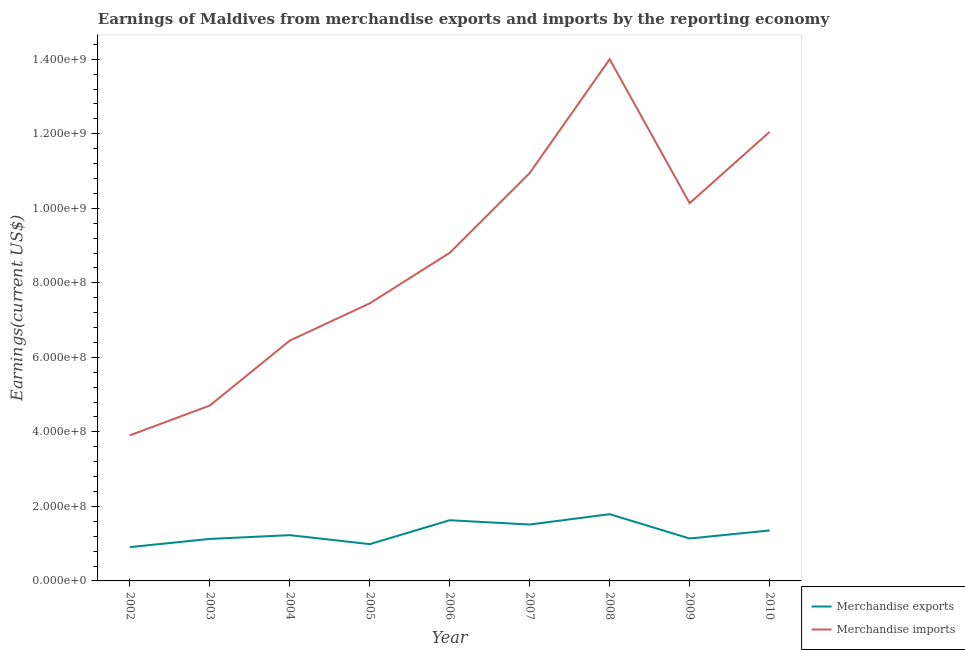How many different coloured lines are there?
Offer a very short reply. 2. Is the number of lines equal to the number of legend labels?
Make the answer very short. Yes. What is the earnings from merchandise exports in 2010?
Your response must be concise. 1.35e+08. Across all years, what is the maximum earnings from merchandise exports?
Make the answer very short. 1.79e+08. Across all years, what is the minimum earnings from merchandise exports?
Your response must be concise. 9.07e+07. In which year was the earnings from merchandise imports maximum?
Offer a very short reply. 2008. In which year was the earnings from merchandise imports minimum?
Give a very brief answer. 2002. What is the total earnings from merchandise imports in the graph?
Offer a terse response. 7.85e+09. What is the difference between the earnings from merchandise imports in 2002 and that in 2003?
Keep it short and to the point. -7.99e+07. What is the difference between the earnings from merchandise imports in 2002 and the earnings from merchandise exports in 2008?
Make the answer very short. 2.12e+08. What is the average earnings from merchandise exports per year?
Provide a succinct answer. 1.30e+08. In the year 2010, what is the difference between the earnings from merchandise imports and earnings from merchandise exports?
Offer a very short reply. 1.07e+09. What is the ratio of the earnings from merchandise imports in 2007 to that in 2010?
Offer a terse response. 0.91. Is the difference between the earnings from merchandise exports in 2008 and 2009 greater than the difference between the earnings from merchandise imports in 2008 and 2009?
Offer a very short reply. No. What is the difference between the highest and the second highest earnings from merchandise imports?
Make the answer very short. 1.95e+08. What is the difference between the highest and the lowest earnings from merchandise exports?
Offer a terse response. 8.84e+07. Is the sum of the earnings from merchandise exports in 2002 and 2007 greater than the maximum earnings from merchandise imports across all years?
Make the answer very short. No. Does the earnings from merchandise exports monotonically increase over the years?
Your answer should be compact. No. Is the earnings from merchandise imports strictly greater than the earnings from merchandise exports over the years?
Provide a short and direct response. Yes. How many lines are there?
Ensure brevity in your answer.  2. How many years are there in the graph?
Make the answer very short. 9. What is the difference between two consecutive major ticks on the Y-axis?
Give a very brief answer. 2.00e+08. How many legend labels are there?
Provide a succinct answer. 2. How are the legend labels stacked?
Give a very brief answer. Vertical. What is the title of the graph?
Make the answer very short. Earnings of Maldives from merchandise exports and imports by the reporting economy. What is the label or title of the Y-axis?
Provide a succinct answer. Earnings(current US$). What is the Earnings(current US$) in Merchandise exports in 2002?
Make the answer very short. 9.07e+07. What is the Earnings(current US$) in Merchandise imports in 2002?
Provide a short and direct response. 3.91e+08. What is the Earnings(current US$) in Merchandise exports in 2003?
Make the answer very short. 1.13e+08. What is the Earnings(current US$) in Merchandise imports in 2003?
Your response must be concise. 4.71e+08. What is the Earnings(current US$) of Merchandise exports in 2004?
Offer a terse response. 1.23e+08. What is the Earnings(current US$) in Merchandise imports in 2004?
Provide a succinct answer. 6.45e+08. What is the Earnings(current US$) in Merchandise exports in 2005?
Make the answer very short. 9.87e+07. What is the Earnings(current US$) in Merchandise imports in 2005?
Offer a very short reply. 7.45e+08. What is the Earnings(current US$) of Merchandise exports in 2006?
Your answer should be very brief. 1.63e+08. What is the Earnings(current US$) of Merchandise imports in 2006?
Give a very brief answer. 8.81e+08. What is the Earnings(current US$) in Merchandise exports in 2007?
Provide a succinct answer. 1.51e+08. What is the Earnings(current US$) in Merchandise imports in 2007?
Offer a terse response. 1.09e+09. What is the Earnings(current US$) of Merchandise exports in 2008?
Provide a succinct answer. 1.79e+08. What is the Earnings(current US$) in Merchandise imports in 2008?
Make the answer very short. 1.40e+09. What is the Earnings(current US$) in Merchandise exports in 2009?
Keep it short and to the point. 1.14e+08. What is the Earnings(current US$) of Merchandise imports in 2009?
Offer a terse response. 1.01e+09. What is the Earnings(current US$) in Merchandise exports in 2010?
Your answer should be very brief. 1.35e+08. What is the Earnings(current US$) in Merchandise imports in 2010?
Provide a short and direct response. 1.20e+09. Across all years, what is the maximum Earnings(current US$) of Merchandise exports?
Keep it short and to the point. 1.79e+08. Across all years, what is the maximum Earnings(current US$) of Merchandise imports?
Give a very brief answer. 1.40e+09. Across all years, what is the minimum Earnings(current US$) of Merchandise exports?
Your answer should be very brief. 9.07e+07. Across all years, what is the minimum Earnings(current US$) in Merchandise imports?
Ensure brevity in your answer.  3.91e+08. What is the total Earnings(current US$) in Merchandise exports in the graph?
Provide a succinct answer. 1.17e+09. What is the total Earnings(current US$) in Merchandise imports in the graph?
Make the answer very short. 7.85e+09. What is the difference between the Earnings(current US$) of Merchandise exports in 2002 and that in 2003?
Give a very brief answer. -2.20e+07. What is the difference between the Earnings(current US$) of Merchandise imports in 2002 and that in 2003?
Offer a terse response. -7.99e+07. What is the difference between the Earnings(current US$) of Merchandise exports in 2002 and that in 2004?
Make the answer very short. -3.21e+07. What is the difference between the Earnings(current US$) in Merchandise imports in 2002 and that in 2004?
Give a very brief answer. -2.54e+08. What is the difference between the Earnings(current US$) in Merchandise exports in 2002 and that in 2005?
Your answer should be compact. -8.01e+06. What is the difference between the Earnings(current US$) of Merchandise imports in 2002 and that in 2005?
Your answer should be very brief. -3.54e+08. What is the difference between the Earnings(current US$) of Merchandise exports in 2002 and that in 2006?
Offer a terse response. -7.21e+07. What is the difference between the Earnings(current US$) in Merchandise imports in 2002 and that in 2006?
Give a very brief answer. -4.90e+08. What is the difference between the Earnings(current US$) of Merchandise exports in 2002 and that in 2007?
Your answer should be very brief. -6.07e+07. What is the difference between the Earnings(current US$) in Merchandise imports in 2002 and that in 2007?
Ensure brevity in your answer.  -7.04e+08. What is the difference between the Earnings(current US$) of Merchandise exports in 2002 and that in 2008?
Your response must be concise. -8.84e+07. What is the difference between the Earnings(current US$) of Merchandise imports in 2002 and that in 2008?
Ensure brevity in your answer.  -1.01e+09. What is the difference between the Earnings(current US$) of Merchandise exports in 2002 and that in 2009?
Give a very brief answer. -2.31e+07. What is the difference between the Earnings(current US$) of Merchandise imports in 2002 and that in 2009?
Your answer should be compact. -6.23e+08. What is the difference between the Earnings(current US$) in Merchandise exports in 2002 and that in 2010?
Your response must be concise. -4.47e+07. What is the difference between the Earnings(current US$) of Merchandise imports in 2002 and that in 2010?
Make the answer very short. -8.14e+08. What is the difference between the Earnings(current US$) in Merchandise exports in 2003 and that in 2004?
Make the answer very short. -1.01e+07. What is the difference between the Earnings(current US$) of Merchandise imports in 2003 and that in 2004?
Provide a succinct answer. -1.74e+08. What is the difference between the Earnings(current US$) in Merchandise exports in 2003 and that in 2005?
Provide a succinct answer. 1.40e+07. What is the difference between the Earnings(current US$) of Merchandise imports in 2003 and that in 2005?
Give a very brief answer. -2.74e+08. What is the difference between the Earnings(current US$) of Merchandise exports in 2003 and that in 2006?
Your response must be concise. -5.01e+07. What is the difference between the Earnings(current US$) of Merchandise imports in 2003 and that in 2006?
Offer a very short reply. -4.10e+08. What is the difference between the Earnings(current US$) of Merchandise exports in 2003 and that in 2007?
Your answer should be compact. -3.87e+07. What is the difference between the Earnings(current US$) of Merchandise imports in 2003 and that in 2007?
Give a very brief answer. -6.24e+08. What is the difference between the Earnings(current US$) in Merchandise exports in 2003 and that in 2008?
Ensure brevity in your answer.  -6.64e+07. What is the difference between the Earnings(current US$) of Merchandise imports in 2003 and that in 2008?
Give a very brief answer. -9.29e+08. What is the difference between the Earnings(current US$) of Merchandise exports in 2003 and that in 2009?
Ensure brevity in your answer.  -1.13e+06. What is the difference between the Earnings(current US$) in Merchandise imports in 2003 and that in 2009?
Provide a short and direct response. -5.43e+08. What is the difference between the Earnings(current US$) in Merchandise exports in 2003 and that in 2010?
Provide a short and direct response. -2.27e+07. What is the difference between the Earnings(current US$) of Merchandise imports in 2003 and that in 2010?
Provide a short and direct response. -7.34e+08. What is the difference between the Earnings(current US$) in Merchandise exports in 2004 and that in 2005?
Offer a very short reply. 2.41e+07. What is the difference between the Earnings(current US$) in Merchandise imports in 2004 and that in 2005?
Your answer should be compact. -9.99e+07. What is the difference between the Earnings(current US$) in Merchandise exports in 2004 and that in 2006?
Your answer should be very brief. -4.00e+07. What is the difference between the Earnings(current US$) in Merchandise imports in 2004 and that in 2006?
Keep it short and to the point. -2.36e+08. What is the difference between the Earnings(current US$) of Merchandise exports in 2004 and that in 2007?
Provide a short and direct response. -2.86e+07. What is the difference between the Earnings(current US$) in Merchandise imports in 2004 and that in 2007?
Keep it short and to the point. -4.50e+08. What is the difference between the Earnings(current US$) of Merchandise exports in 2004 and that in 2008?
Keep it short and to the point. -5.63e+07. What is the difference between the Earnings(current US$) in Merchandise imports in 2004 and that in 2008?
Provide a succinct answer. -7.55e+08. What is the difference between the Earnings(current US$) of Merchandise exports in 2004 and that in 2009?
Your answer should be compact. 8.99e+06. What is the difference between the Earnings(current US$) of Merchandise imports in 2004 and that in 2009?
Give a very brief answer. -3.69e+08. What is the difference between the Earnings(current US$) in Merchandise exports in 2004 and that in 2010?
Ensure brevity in your answer.  -1.26e+07. What is the difference between the Earnings(current US$) of Merchandise imports in 2004 and that in 2010?
Ensure brevity in your answer.  -5.60e+08. What is the difference between the Earnings(current US$) of Merchandise exports in 2005 and that in 2006?
Offer a terse response. -6.41e+07. What is the difference between the Earnings(current US$) in Merchandise imports in 2005 and that in 2006?
Your answer should be compact. -1.36e+08. What is the difference between the Earnings(current US$) in Merchandise exports in 2005 and that in 2007?
Your answer should be compact. -5.27e+07. What is the difference between the Earnings(current US$) in Merchandise imports in 2005 and that in 2007?
Your answer should be very brief. -3.50e+08. What is the difference between the Earnings(current US$) of Merchandise exports in 2005 and that in 2008?
Provide a short and direct response. -8.04e+07. What is the difference between the Earnings(current US$) in Merchandise imports in 2005 and that in 2008?
Give a very brief answer. -6.55e+08. What is the difference between the Earnings(current US$) in Merchandise exports in 2005 and that in 2009?
Provide a short and direct response. -1.51e+07. What is the difference between the Earnings(current US$) in Merchandise imports in 2005 and that in 2009?
Your answer should be compact. -2.69e+08. What is the difference between the Earnings(current US$) in Merchandise exports in 2005 and that in 2010?
Provide a short and direct response. -3.67e+07. What is the difference between the Earnings(current US$) in Merchandise imports in 2005 and that in 2010?
Offer a very short reply. -4.60e+08. What is the difference between the Earnings(current US$) in Merchandise exports in 2006 and that in 2007?
Give a very brief answer. 1.15e+07. What is the difference between the Earnings(current US$) in Merchandise imports in 2006 and that in 2007?
Ensure brevity in your answer.  -2.14e+08. What is the difference between the Earnings(current US$) of Merchandise exports in 2006 and that in 2008?
Your response must be concise. -1.63e+07. What is the difference between the Earnings(current US$) in Merchandise imports in 2006 and that in 2008?
Provide a succinct answer. -5.19e+08. What is the difference between the Earnings(current US$) of Merchandise exports in 2006 and that in 2009?
Offer a terse response. 4.90e+07. What is the difference between the Earnings(current US$) in Merchandise imports in 2006 and that in 2009?
Your answer should be very brief. -1.33e+08. What is the difference between the Earnings(current US$) in Merchandise exports in 2006 and that in 2010?
Provide a succinct answer. 2.75e+07. What is the difference between the Earnings(current US$) in Merchandise imports in 2006 and that in 2010?
Offer a very short reply. -3.24e+08. What is the difference between the Earnings(current US$) in Merchandise exports in 2007 and that in 2008?
Ensure brevity in your answer.  -2.77e+07. What is the difference between the Earnings(current US$) of Merchandise imports in 2007 and that in 2008?
Make the answer very short. -3.05e+08. What is the difference between the Earnings(current US$) of Merchandise exports in 2007 and that in 2009?
Give a very brief answer. 3.75e+07. What is the difference between the Earnings(current US$) of Merchandise imports in 2007 and that in 2009?
Make the answer very short. 8.09e+07. What is the difference between the Earnings(current US$) in Merchandise exports in 2007 and that in 2010?
Give a very brief answer. 1.60e+07. What is the difference between the Earnings(current US$) in Merchandise imports in 2007 and that in 2010?
Offer a very short reply. -1.10e+08. What is the difference between the Earnings(current US$) in Merchandise exports in 2008 and that in 2009?
Keep it short and to the point. 6.53e+07. What is the difference between the Earnings(current US$) of Merchandise imports in 2008 and that in 2009?
Your answer should be compact. 3.86e+08. What is the difference between the Earnings(current US$) in Merchandise exports in 2008 and that in 2010?
Ensure brevity in your answer.  4.37e+07. What is the difference between the Earnings(current US$) of Merchandise imports in 2008 and that in 2010?
Your answer should be very brief. 1.95e+08. What is the difference between the Earnings(current US$) of Merchandise exports in 2009 and that in 2010?
Make the answer very short. -2.15e+07. What is the difference between the Earnings(current US$) in Merchandise imports in 2009 and that in 2010?
Provide a short and direct response. -1.91e+08. What is the difference between the Earnings(current US$) of Merchandise exports in 2002 and the Earnings(current US$) of Merchandise imports in 2003?
Offer a very short reply. -3.80e+08. What is the difference between the Earnings(current US$) of Merchandise exports in 2002 and the Earnings(current US$) of Merchandise imports in 2004?
Give a very brief answer. -5.54e+08. What is the difference between the Earnings(current US$) of Merchandise exports in 2002 and the Earnings(current US$) of Merchandise imports in 2005?
Give a very brief answer. -6.54e+08. What is the difference between the Earnings(current US$) of Merchandise exports in 2002 and the Earnings(current US$) of Merchandise imports in 2006?
Give a very brief answer. -7.90e+08. What is the difference between the Earnings(current US$) of Merchandise exports in 2002 and the Earnings(current US$) of Merchandise imports in 2007?
Make the answer very short. -1.00e+09. What is the difference between the Earnings(current US$) in Merchandise exports in 2002 and the Earnings(current US$) in Merchandise imports in 2008?
Give a very brief answer. -1.31e+09. What is the difference between the Earnings(current US$) of Merchandise exports in 2002 and the Earnings(current US$) of Merchandise imports in 2009?
Keep it short and to the point. -9.23e+08. What is the difference between the Earnings(current US$) of Merchandise exports in 2002 and the Earnings(current US$) of Merchandise imports in 2010?
Give a very brief answer. -1.11e+09. What is the difference between the Earnings(current US$) in Merchandise exports in 2003 and the Earnings(current US$) in Merchandise imports in 2004?
Offer a very short reply. -5.32e+08. What is the difference between the Earnings(current US$) in Merchandise exports in 2003 and the Earnings(current US$) in Merchandise imports in 2005?
Offer a very short reply. -6.32e+08. What is the difference between the Earnings(current US$) of Merchandise exports in 2003 and the Earnings(current US$) of Merchandise imports in 2006?
Your answer should be compact. -7.68e+08. What is the difference between the Earnings(current US$) in Merchandise exports in 2003 and the Earnings(current US$) in Merchandise imports in 2007?
Make the answer very short. -9.82e+08. What is the difference between the Earnings(current US$) of Merchandise exports in 2003 and the Earnings(current US$) of Merchandise imports in 2008?
Ensure brevity in your answer.  -1.29e+09. What is the difference between the Earnings(current US$) in Merchandise exports in 2003 and the Earnings(current US$) in Merchandise imports in 2009?
Offer a terse response. -9.01e+08. What is the difference between the Earnings(current US$) of Merchandise exports in 2003 and the Earnings(current US$) of Merchandise imports in 2010?
Provide a succinct answer. -1.09e+09. What is the difference between the Earnings(current US$) of Merchandise exports in 2004 and the Earnings(current US$) of Merchandise imports in 2005?
Your answer should be very brief. -6.22e+08. What is the difference between the Earnings(current US$) of Merchandise exports in 2004 and the Earnings(current US$) of Merchandise imports in 2006?
Keep it short and to the point. -7.58e+08. What is the difference between the Earnings(current US$) in Merchandise exports in 2004 and the Earnings(current US$) in Merchandise imports in 2007?
Ensure brevity in your answer.  -9.72e+08. What is the difference between the Earnings(current US$) of Merchandise exports in 2004 and the Earnings(current US$) of Merchandise imports in 2008?
Your answer should be very brief. -1.28e+09. What is the difference between the Earnings(current US$) of Merchandise exports in 2004 and the Earnings(current US$) of Merchandise imports in 2009?
Provide a short and direct response. -8.91e+08. What is the difference between the Earnings(current US$) of Merchandise exports in 2004 and the Earnings(current US$) of Merchandise imports in 2010?
Ensure brevity in your answer.  -1.08e+09. What is the difference between the Earnings(current US$) in Merchandise exports in 2005 and the Earnings(current US$) in Merchandise imports in 2006?
Your answer should be compact. -7.82e+08. What is the difference between the Earnings(current US$) of Merchandise exports in 2005 and the Earnings(current US$) of Merchandise imports in 2007?
Provide a short and direct response. -9.96e+08. What is the difference between the Earnings(current US$) in Merchandise exports in 2005 and the Earnings(current US$) in Merchandise imports in 2008?
Ensure brevity in your answer.  -1.30e+09. What is the difference between the Earnings(current US$) of Merchandise exports in 2005 and the Earnings(current US$) of Merchandise imports in 2009?
Offer a terse response. -9.15e+08. What is the difference between the Earnings(current US$) in Merchandise exports in 2005 and the Earnings(current US$) in Merchandise imports in 2010?
Ensure brevity in your answer.  -1.11e+09. What is the difference between the Earnings(current US$) of Merchandise exports in 2006 and the Earnings(current US$) of Merchandise imports in 2007?
Provide a succinct answer. -9.32e+08. What is the difference between the Earnings(current US$) of Merchandise exports in 2006 and the Earnings(current US$) of Merchandise imports in 2008?
Provide a succinct answer. -1.24e+09. What is the difference between the Earnings(current US$) of Merchandise exports in 2006 and the Earnings(current US$) of Merchandise imports in 2009?
Keep it short and to the point. -8.51e+08. What is the difference between the Earnings(current US$) of Merchandise exports in 2006 and the Earnings(current US$) of Merchandise imports in 2010?
Your answer should be very brief. -1.04e+09. What is the difference between the Earnings(current US$) of Merchandise exports in 2007 and the Earnings(current US$) of Merchandise imports in 2008?
Keep it short and to the point. -1.25e+09. What is the difference between the Earnings(current US$) in Merchandise exports in 2007 and the Earnings(current US$) in Merchandise imports in 2009?
Your response must be concise. -8.62e+08. What is the difference between the Earnings(current US$) of Merchandise exports in 2007 and the Earnings(current US$) of Merchandise imports in 2010?
Make the answer very short. -1.05e+09. What is the difference between the Earnings(current US$) of Merchandise exports in 2008 and the Earnings(current US$) of Merchandise imports in 2009?
Ensure brevity in your answer.  -8.35e+08. What is the difference between the Earnings(current US$) of Merchandise exports in 2008 and the Earnings(current US$) of Merchandise imports in 2010?
Provide a short and direct response. -1.03e+09. What is the difference between the Earnings(current US$) in Merchandise exports in 2009 and the Earnings(current US$) in Merchandise imports in 2010?
Offer a very short reply. -1.09e+09. What is the average Earnings(current US$) of Merchandise exports per year?
Your response must be concise. 1.30e+08. What is the average Earnings(current US$) in Merchandise imports per year?
Make the answer very short. 8.72e+08. In the year 2002, what is the difference between the Earnings(current US$) of Merchandise exports and Earnings(current US$) of Merchandise imports?
Provide a short and direct response. -3.00e+08. In the year 2003, what is the difference between the Earnings(current US$) of Merchandise exports and Earnings(current US$) of Merchandise imports?
Make the answer very short. -3.58e+08. In the year 2004, what is the difference between the Earnings(current US$) of Merchandise exports and Earnings(current US$) of Merchandise imports?
Your response must be concise. -5.22e+08. In the year 2005, what is the difference between the Earnings(current US$) of Merchandise exports and Earnings(current US$) of Merchandise imports?
Provide a succinct answer. -6.46e+08. In the year 2006, what is the difference between the Earnings(current US$) in Merchandise exports and Earnings(current US$) in Merchandise imports?
Give a very brief answer. -7.18e+08. In the year 2007, what is the difference between the Earnings(current US$) in Merchandise exports and Earnings(current US$) in Merchandise imports?
Provide a succinct answer. -9.43e+08. In the year 2008, what is the difference between the Earnings(current US$) in Merchandise exports and Earnings(current US$) in Merchandise imports?
Give a very brief answer. -1.22e+09. In the year 2009, what is the difference between the Earnings(current US$) in Merchandise exports and Earnings(current US$) in Merchandise imports?
Make the answer very short. -9.00e+08. In the year 2010, what is the difference between the Earnings(current US$) of Merchandise exports and Earnings(current US$) of Merchandise imports?
Provide a succinct answer. -1.07e+09. What is the ratio of the Earnings(current US$) in Merchandise exports in 2002 to that in 2003?
Your answer should be very brief. 0.8. What is the ratio of the Earnings(current US$) of Merchandise imports in 2002 to that in 2003?
Give a very brief answer. 0.83. What is the ratio of the Earnings(current US$) in Merchandise exports in 2002 to that in 2004?
Offer a very short reply. 0.74. What is the ratio of the Earnings(current US$) in Merchandise imports in 2002 to that in 2004?
Your answer should be very brief. 0.61. What is the ratio of the Earnings(current US$) of Merchandise exports in 2002 to that in 2005?
Provide a short and direct response. 0.92. What is the ratio of the Earnings(current US$) in Merchandise imports in 2002 to that in 2005?
Offer a terse response. 0.52. What is the ratio of the Earnings(current US$) of Merchandise exports in 2002 to that in 2006?
Provide a succinct answer. 0.56. What is the ratio of the Earnings(current US$) in Merchandise imports in 2002 to that in 2006?
Your answer should be compact. 0.44. What is the ratio of the Earnings(current US$) in Merchandise exports in 2002 to that in 2007?
Give a very brief answer. 0.6. What is the ratio of the Earnings(current US$) in Merchandise imports in 2002 to that in 2007?
Your response must be concise. 0.36. What is the ratio of the Earnings(current US$) in Merchandise exports in 2002 to that in 2008?
Keep it short and to the point. 0.51. What is the ratio of the Earnings(current US$) in Merchandise imports in 2002 to that in 2008?
Provide a succinct answer. 0.28. What is the ratio of the Earnings(current US$) in Merchandise exports in 2002 to that in 2009?
Your answer should be very brief. 0.8. What is the ratio of the Earnings(current US$) in Merchandise imports in 2002 to that in 2009?
Ensure brevity in your answer.  0.39. What is the ratio of the Earnings(current US$) in Merchandise exports in 2002 to that in 2010?
Provide a short and direct response. 0.67. What is the ratio of the Earnings(current US$) in Merchandise imports in 2002 to that in 2010?
Your response must be concise. 0.32. What is the ratio of the Earnings(current US$) of Merchandise exports in 2003 to that in 2004?
Your answer should be very brief. 0.92. What is the ratio of the Earnings(current US$) of Merchandise imports in 2003 to that in 2004?
Your response must be concise. 0.73. What is the ratio of the Earnings(current US$) in Merchandise exports in 2003 to that in 2005?
Your response must be concise. 1.14. What is the ratio of the Earnings(current US$) in Merchandise imports in 2003 to that in 2005?
Give a very brief answer. 0.63. What is the ratio of the Earnings(current US$) of Merchandise exports in 2003 to that in 2006?
Make the answer very short. 0.69. What is the ratio of the Earnings(current US$) in Merchandise imports in 2003 to that in 2006?
Provide a succinct answer. 0.53. What is the ratio of the Earnings(current US$) in Merchandise exports in 2003 to that in 2007?
Offer a terse response. 0.74. What is the ratio of the Earnings(current US$) of Merchandise imports in 2003 to that in 2007?
Your response must be concise. 0.43. What is the ratio of the Earnings(current US$) in Merchandise exports in 2003 to that in 2008?
Make the answer very short. 0.63. What is the ratio of the Earnings(current US$) in Merchandise imports in 2003 to that in 2008?
Keep it short and to the point. 0.34. What is the ratio of the Earnings(current US$) of Merchandise imports in 2003 to that in 2009?
Your answer should be compact. 0.46. What is the ratio of the Earnings(current US$) of Merchandise exports in 2003 to that in 2010?
Provide a short and direct response. 0.83. What is the ratio of the Earnings(current US$) in Merchandise imports in 2003 to that in 2010?
Offer a terse response. 0.39. What is the ratio of the Earnings(current US$) in Merchandise exports in 2004 to that in 2005?
Your answer should be compact. 1.24. What is the ratio of the Earnings(current US$) of Merchandise imports in 2004 to that in 2005?
Offer a terse response. 0.87. What is the ratio of the Earnings(current US$) in Merchandise exports in 2004 to that in 2006?
Offer a very short reply. 0.75. What is the ratio of the Earnings(current US$) in Merchandise imports in 2004 to that in 2006?
Your answer should be compact. 0.73. What is the ratio of the Earnings(current US$) in Merchandise exports in 2004 to that in 2007?
Provide a short and direct response. 0.81. What is the ratio of the Earnings(current US$) in Merchandise imports in 2004 to that in 2007?
Provide a succinct answer. 0.59. What is the ratio of the Earnings(current US$) in Merchandise exports in 2004 to that in 2008?
Ensure brevity in your answer.  0.69. What is the ratio of the Earnings(current US$) in Merchandise imports in 2004 to that in 2008?
Keep it short and to the point. 0.46. What is the ratio of the Earnings(current US$) in Merchandise exports in 2004 to that in 2009?
Your answer should be compact. 1.08. What is the ratio of the Earnings(current US$) of Merchandise imports in 2004 to that in 2009?
Offer a very short reply. 0.64. What is the ratio of the Earnings(current US$) in Merchandise exports in 2004 to that in 2010?
Your answer should be very brief. 0.91. What is the ratio of the Earnings(current US$) in Merchandise imports in 2004 to that in 2010?
Offer a terse response. 0.54. What is the ratio of the Earnings(current US$) of Merchandise exports in 2005 to that in 2006?
Your answer should be compact. 0.61. What is the ratio of the Earnings(current US$) in Merchandise imports in 2005 to that in 2006?
Offer a very short reply. 0.85. What is the ratio of the Earnings(current US$) of Merchandise exports in 2005 to that in 2007?
Ensure brevity in your answer.  0.65. What is the ratio of the Earnings(current US$) in Merchandise imports in 2005 to that in 2007?
Ensure brevity in your answer.  0.68. What is the ratio of the Earnings(current US$) in Merchandise exports in 2005 to that in 2008?
Your answer should be very brief. 0.55. What is the ratio of the Earnings(current US$) in Merchandise imports in 2005 to that in 2008?
Offer a terse response. 0.53. What is the ratio of the Earnings(current US$) of Merchandise exports in 2005 to that in 2009?
Provide a succinct answer. 0.87. What is the ratio of the Earnings(current US$) in Merchandise imports in 2005 to that in 2009?
Offer a very short reply. 0.73. What is the ratio of the Earnings(current US$) in Merchandise exports in 2005 to that in 2010?
Provide a succinct answer. 0.73. What is the ratio of the Earnings(current US$) of Merchandise imports in 2005 to that in 2010?
Ensure brevity in your answer.  0.62. What is the ratio of the Earnings(current US$) in Merchandise exports in 2006 to that in 2007?
Make the answer very short. 1.08. What is the ratio of the Earnings(current US$) of Merchandise imports in 2006 to that in 2007?
Keep it short and to the point. 0.8. What is the ratio of the Earnings(current US$) in Merchandise exports in 2006 to that in 2008?
Offer a very short reply. 0.91. What is the ratio of the Earnings(current US$) of Merchandise imports in 2006 to that in 2008?
Make the answer very short. 0.63. What is the ratio of the Earnings(current US$) of Merchandise exports in 2006 to that in 2009?
Offer a very short reply. 1.43. What is the ratio of the Earnings(current US$) in Merchandise imports in 2006 to that in 2009?
Provide a succinct answer. 0.87. What is the ratio of the Earnings(current US$) of Merchandise exports in 2006 to that in 2010?
Provide a short and direct response. 1.2. What is the ratio of the Earnings(current US$) of Merchandise imports in 2006 to that in 2010?
Your answer should be very brief. 0.73. What is the ratio of the Earnings(current US$) in Merchandise exports in 2007 to that in 2008?
Provide a succinct answer. 0.85. What is the ratio of the Earnings(current US$) in Merchandise imports in 2007 to that in 2008?
Provide a succinct answer. 0.78. What is the ratio of the Earnings(current US$) of Merchandise exports in 2007 to that in 2009?
Keep it short and to the point. 1.33. What is the ratio of the Earnings(current US$) of Merchandise imports in 2007 to that in 2009?
Ensure brevity in your answer.  1.08. What is the ratio of the Earnings(current US$) of Merchandise exports in 2007 to that in 2010?
Your answer should be very brief. 1.12. What is the ratio of the Earnings(current US$) in Merchandise imports in 2007 to that in 2010?
Your answer should be very brief. 0.91. What is the ratio of the Earnings(current US$) of Merchandise exports in 2008 to that in 2009?
Keep it short and to the point. 1.57. What is the ratio of the Earnings(current US$) in Merchandise imports in 2008 to that in 2009?
Your answer should be compact. 1.38. What is the ratio of the Earnings(current US$) of Merchandise exports in 2008 to that in 2010?
Provide a short and direct response. 1.32. What is the ratio of the Earnings(current US$) of Merchandise imports in 2008 to that in 2010?
Provide a succinct answer. 1.16. What is the ratio of the Earnings(current US$) in Merchandise exports in 2009 to that in 2010?
Your answer should be compact. 0.84. What is the ratio of the Earnings(current US$) of Merchandise imports in 2009 to that in 2010?
Make the answer very short. 0.84. What is the difference between the highest and the second highest Earnings(current US$) of Merchandise exports?
Keep it short and to the point. 1.63e+07. What is the difference between the highest and the second highest Earnings(current US$) of Merchandise imports?
Provide a short and direct response. 1.95e+08. What is the difference between the highest and the lowest Earnings(current US$) of Merchandise exports?
Give a very brief answer. 8.84e+07. What is the difference between the highest and the lowest Earnings(current US$) of Merchandise imports?
Your answer should be compact. 1.01e+09. 